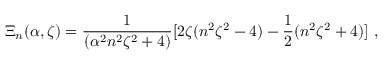Convert formula to latex. <formula><loc_0><loc_0><loc_500><loc_500>\Xi _ { n } ( \alpha , \zeta ) = \frac { 1 } { ( \alpha ^ { 2 } n ^ { 2 } \zeta ^ { 2 } + 4 ) } [ 2 \zeta ( n ^ { 2 } \zeta ^ { 2 } - 4 ) - \frac { 1 } { 2 } ( n ^ { 2 } \zeta ^ { 2 } + 4 ) ] \ ,</formula> 